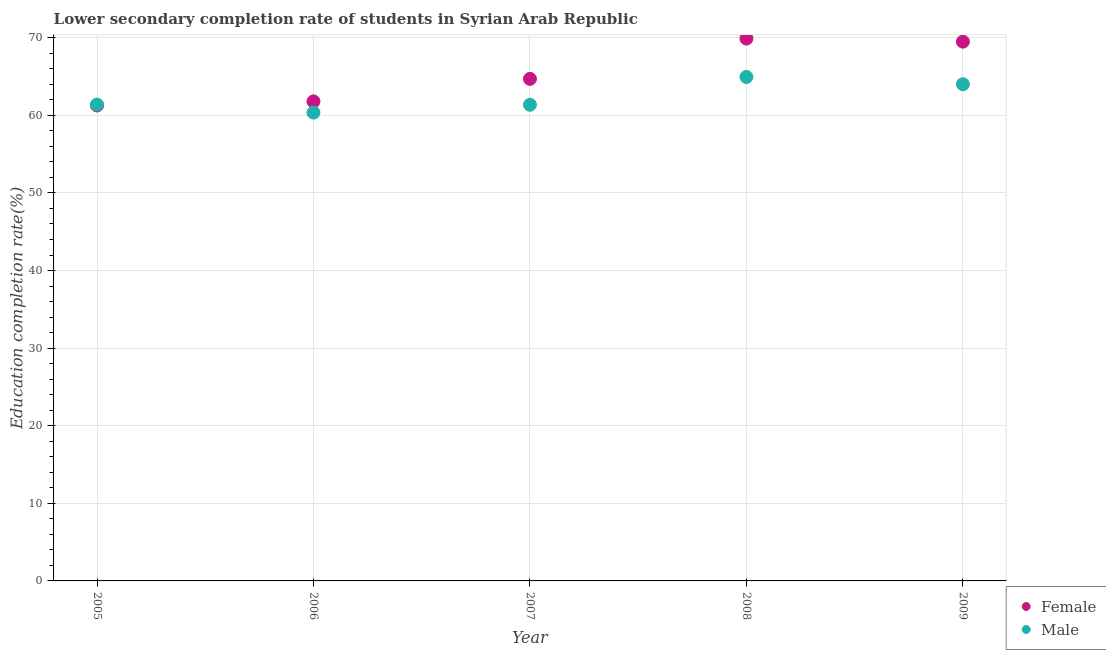Is the number of dotlines equal to the number of legend labels?
Offer a terse response. Yes. What is the education completion rate of female students in 2006?
Your answer should be compact. 61.8. Across all years, what is the maximum education completion rate of male students?
Your answer should be very brief. 64.95. Across all years, what is the minimum education completion rate of female students?
Ensure brevity in your answer.  61.27. In which year was the education completion rate of male students maximum?
Offer a terse response. 2008. In which year was the education completion rate of male students minimum?
Your answer should be very brief. 2006. What is the total education completion rate of male students in the graph?
Provide a succinct answer. 312.07. What is the difference between the education completion rate of male students in 2006 and that in 2009?
Offer a terse response. -3.65. What is the difference between the education completion rate of male students in 2005 and the education completion rate of female students in 2008?
Make the answer very short. -8.51. What is the average education completion rate of female students per year?
Your answer should be very brief. 65.43. In the year 2009, what is the difference between the education completion rate of male students and education completion rate of female students?
Offer a very short reply. -5.49. In how many years, is the education completion rate of male students greater than 54 %?
Ensure brevity in your answer.  5. What is the ratio of the education completion rate of female students in 2008 to that in 2009?
Make the answer very short. 1.01. Is the education completion rate of male students in 2007 less than that in 2008?
Make the answer very short. Yes. Is the difference between the education completion rate of female students in 2005 and 2009 greater than the difference between the education completion rate of male students in 2005 and 2009?
Offer a terse response. No. What is the difference between the highest and the second highest education completion rate of female students?
Keep it short and to the point. 0.4. What is the difference between the highest and the lowest education completion rate of male students?
Your answer should be very brief. 4.59. Is the education completion rate of male students strictly greater than the education completion rate of female students over the years?
Give a very brief answer. No. How many years are there in the graph?
Provide a short and direct response. 5. Does the graph contain any zero values?
Your answer should be very brief. No. How many legend labels are there?
Your answer should be compact. 2. What is the title of the graph?
Provide a succinct answer. Lower secondary completion rate of students in Syrian Arab Republic. What is the label or title of the Y-axis?
Offer a terse response. Education completion rate(%). What is the Education completion rate(%) in Female in 2005?
Give a very brief answer. 61.27. What is the Education completion rate(%) of Male in 2005?
Your answer should be very brief. 61.39. What is the Education completion rate(%) in Female in 2006?
Ensure brevity in your answer.  61.8. What is the Education completion rate(%) in Male in 2006?
Offer a terse response. 60.36. What is the Education completion rate(%) of Female in 2007?
Make the answer very short. 64.7. What is the Education completion rate(%) in Male in 2007?
Provide a succinct answer. 61.36. What is the Education completion rate(%) of Female in 2008?
Your response must be concise. 69.9. What is the Education completion rate(%) in Male in 2008?
Provide a succinct answer. 64.95. What is the Education completion rate(%) of Female in 2009?
Provide a short and direct response. 69.5. What is the Education completion rate(%) in Male in 2009?
Offer a terse response. 64.01. Across all years, what is the maximum Education completion rate(%) of Female?
Your response must be concise. 69.9. Across all years, what is the maximum Education completion rate(%) of Male?
Offer a very short reply. 64.95. Across all years, what is the minimum Education completion rate(%) of Female?
Keep it short and to the point. 61.27. Across all years, what is the minimum Education completion rate(%) in Male?
Ensure brevity in your answer.  60.36. What is the total Education completion rate(%) of Female in the graph?
Ensure brevity in your answer.  327.17. What is the total Education completion rate(%) of Male in the graph?
Your response must be concise. 312.07. What is the difference between the Education completion rate(%) of Female in 2005 and that in 2006?
Provide a short and direct response. -0.53. What is the difference between the Education completion rate(%) in Male in 2005 and that in 2006?
Your answer should be compact. 1.03. What is the difference between the Education completion rate(%) of Female in 2005 and that in 2007?
Your answer should be compact. -3.43. What is the difference between the Education completion rate(%) of Male in 2005 and that in 2007?
Provide a short and direct response. 0.02. What is the difference between the Education completion rate(%) of Female in 2005 and that in 2008?
Make the answer very short. -8.62. What is the difference between the Education completion rate(%) in Male in 2005 and that in 2008?
Give a very brief answer. -3.56. What is the difference between the Education completion rate(%) in Female in 2005 and that in 2009?
Your answer should be compact. -8.23. What is the difference between the Education completion rate(%) of Male in 2005 and that in 2009?
Make the answer very short. -2.62. What is the difference between the Education completion rate(%) in Female in 2006 and that in 2007?
Your response must be concise. -2.9. What is the difference between the Education completion rate(%) in Male in 2006 and that in 2007?
Give a very brief answer. -1.01. What is the difference between the Education completion rate(%) of Female in 2006 and that in 2008?
Ensure brevity in your answer.  -8.1. What is the difference between the Education completion rate(%) in Male in 2006 and that in 2008?
Offer a very short reply. -4.59. What is the difference between the Education completion rate(%) of Female in 2006 and that in 2009?
Give a very brief answer. -7.7. What is the difference between the Education completion rate(%) in Male in 2006 and that in 2009?
Offer a very short reply. -3.65. What is the difference between the Education completion rate(%) in Female in 2007 and that in 2008?
Your response must be concise. -5.19. What is the difference between the Education completion rate(%) in Male in 2007 and that in 2008?
Your answer should be very brief. -3.59. What is the difference between the Education completion rate(%) of Female in 2007 and that in 2009?
Make the answer very short. -4.79. What is the difference between the Education completion rate(%) of Male in 2007 and that in 2009?
Offer a terse response. -2.65. What is the difference between the Education completion rate(%) of Female in 2008 and that in 2009?
Give a very brief answer. 0.4. What is the difference between the Education completion rate(%) of Male in 2008 and that in 2009?
Your response must be concise. 0.94. What is the difference between the Education completion rate(%) in Female in 2005 and the Education completion rate(%) in Male in 2007?
Ensure brevity in your answer.  -0.09. What is the difference between the Education completion rate(%) of Female in 2005 and the Education completion rate(%) of Male in 2008?
Offer a very short reply. -3.68. What is the difference between the Education completion rate(%) of Female in 2005 and the Education completion rate(%) of Male in 2009?
Offer a very short reply. -2.74. What is the difference between the Education completion rate(%) in Female in 2006 and the Education completion rate(%) in Male in 2007?
Keep it short and to the point. 0.43. What is the difference between the Education completion rate(%) of Female in 2006 and the Education completion rate(%) of Male in 2008?
Ensure brevity in your answer.  -3.15. What is the difference between the Education completion rate(%) of Female in 2006 and the Education completion rate(%) of Male in 2009?
Your answer should be compact. -2.21. What is the difference between the Education completion rate(%) of Female in 2007 and the Education completion rate(%) of Male in 2008?
Keep it short and to the point. -0.25. What is the difference between the Education completion rate(%) in Female in 2007 and the Education completion rate(%) in Male in 2009?
Offer a terse response. 0.69. What is the difference between the Education completion rate(%) in Female in 2008 and the Education completion rate(%) in Male in 2009?
Provide a short and direct response. 5.88. What is the average Education completion rate(%) in Female per year?
Offer a terse response. 65.43. What is the average Education completion rate(%) in Male per year?
Make the answer very short. 62.41. In the year 2005, what is the difference between the Education completion rate(%) of Female and Education completion rate(%) of Male?
Your answer should be compact. -0.12. In the year 2006, what is the difference between the Education completion rate(%) in Female and Education completion rate(%) in Male?
Offer a very short reply. 1.44. In the year 2007, what is the difference between the Education completion rate(%) in Female and Education completion rate(%) in Male?
Your answer should be compact. 3.34. In the year 2008, what is the difference between the Education completion rate(%) in Female and Education completion rate(%) in Male?
Your answer should be compact. 4.95. In the year 2009, what is the difference between the Education completion rate(%) of Female and Education completion rate(%) of Male?
Offer a terse response. 5.49. What is the ratio of the Education completion rate(%) of Female in 2005 to that in 2006?
Your answer should be compact. 0.99. What is the ratio of the Education completion rate(%) of Male in 2005 to that in 2006?
Give a very brief answer. 1.02. What is the ratio of the Education completion rate(%) of Female in 2005 to that in 2007?
Offer a very short reply. 0.95. What is the ratio of the Education completion rate(%) in Female in 2005 to that in 2008?
Offer a terse response. 0.88. What is the ratio of the Education completion rate(%) of Male in 2005 to that in 2008?
Make the answer very short. 0.95. What is the ratio of the Education completion rate(%) in Female in 2005 to that in 2009?
Offer a very short reply. 0.88. What is the ratio of the Education completion rate(%) of Male in 2005 to that in 2009?
Offer a very short reply. 0.96. What is the ratio of the Education completion rate(%) of Female in 2006 to that in 2007?
Your answer should be very brief. 0.96. What is the ratio of the Education completion rate(%) in Male in 2006 to that in 2007?
Your answer should be compact. 0.98. What is the ratio of the Education completion rate(%) of Female in 2006 to that in 2008?
Give a very brief answer. 0.88. What is the ratio of the Education completion rate(%) of Male in 2006 to that in 2008?
Your response must be concise. 0.93. What is the ratio of the Education completion rate(%) of Female in 2006 to that in 2009?
Keep it short and to the point. 0.89. What is the ratio of the Education completion rate(%) in Male in 2006 to that in 2009?
Give a very brief answer. 0.94. What is the ratio of the Education completion rate(%) of Female in 2007 to that in 2008?
Make the answer very short. 0.93. What is the ratio of the Education completion rate(%) in Male in 2007 to that in 2008?
Provide a succinct answer. 0.94. What is the ratio of the Education completion rate(%) of Male in 2007 to that in 2009?
Provide a succinct answer. 0.96. What is the ratio of the Education completion rate(%) of Male in 2008 to that in 2009?
Offer a very short reply. 1.01. What is the difference between the highest and the second highest Education completion rate(%) of Female?
Offer a terse response. 0.4. What is the difference between the highest and the second highest Education completion rate(%) in Male?
Your answer should be compact. 0.94. What is the difference between the highest and the lowest Education completion rate(%) of Female?
Offer a terse response. 8.62. What is the difference between the highest and the lowest Education completion rate(%) of Male?
Your answer should be very brief. 4.59. 